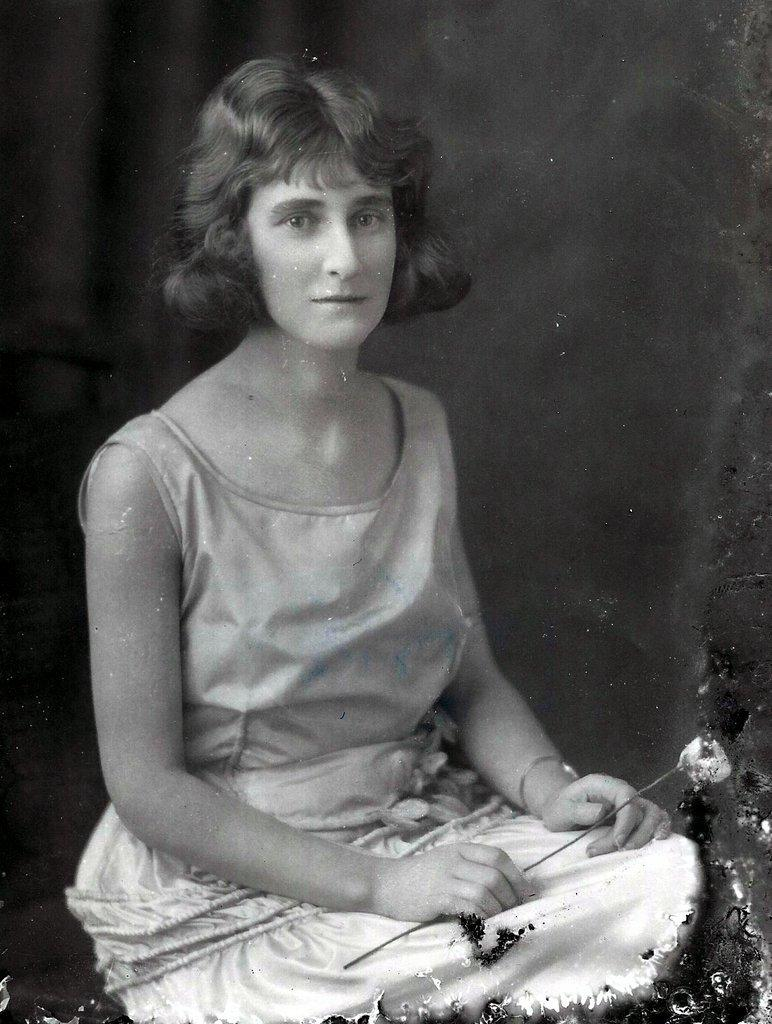What is the main subject of the image? The main subject of the image is a man. What is the man wearing? The man is wearing a t-shirt and shorts. What is the man holding in the image? The man is holding a flower. Can you describe the background of the image? The background of the image is dark. What type of structure is being built in the image? There is no structure being built in the image; it features a man holding a flower against a dark background. How many pins are visible in the image? There are no pins present in the image. 